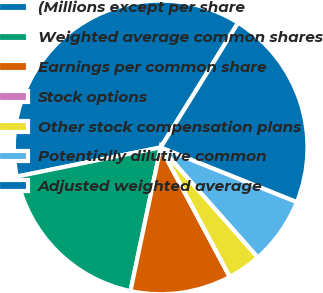<chart> <loc_0><loc_0><loc_500><loc_500><pie_chart><fcel>(Millions except per share<fcel>Weighted average common shares<fcel>Earnings per common share<fcel>Stock options<fcel>Other stock compensation plans<fcel>Potentially dilutive common<fcel>Adjusted weighted average<nl><fcel>37.03%<fcel>18.52%<fcel>11.11%<fcel>0.0%<fcel>3.71%<fcel>7.41%<fcel>22.22%<nl></chart> 